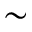Convert formula to latex. <formula><loc_0><loc_0><loc_500><loc_500>\sim</formula> 